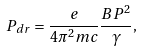Convert formula to latex. <formula><loc_0><loc_0><loc_500><loc_500>P _ { d r } = \frac { e } { 4 \pi ^ { 2 } m c } \frac { B P ^ { 2 } } { \gamma } ,</formula> 